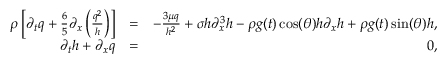Convert formula to latex. <formula><loc_0><loc_0><loc_500><loc_500>\begin{array} { r l r } { \rho \left [ \partial _ { t } q + \frac { 6 } { 5 } \partial _ { x } \left ( \frac { q ^ { 2 } } { h } \right ) \right ] } & { = } & { - \frac { 3 \mu q } { h ^ { 2 } } + \sigma h \partial _ { x } ^ { 3 } h - \rho g ( t ) \cos ( \theta ) h \partial _ { x } h + \rho g ( t ) \sin ( \theta ) h , } \\ { \partial _ { t } h + \partial _ { x } q } & { = } & { 0 , } \end{array}</formula> 